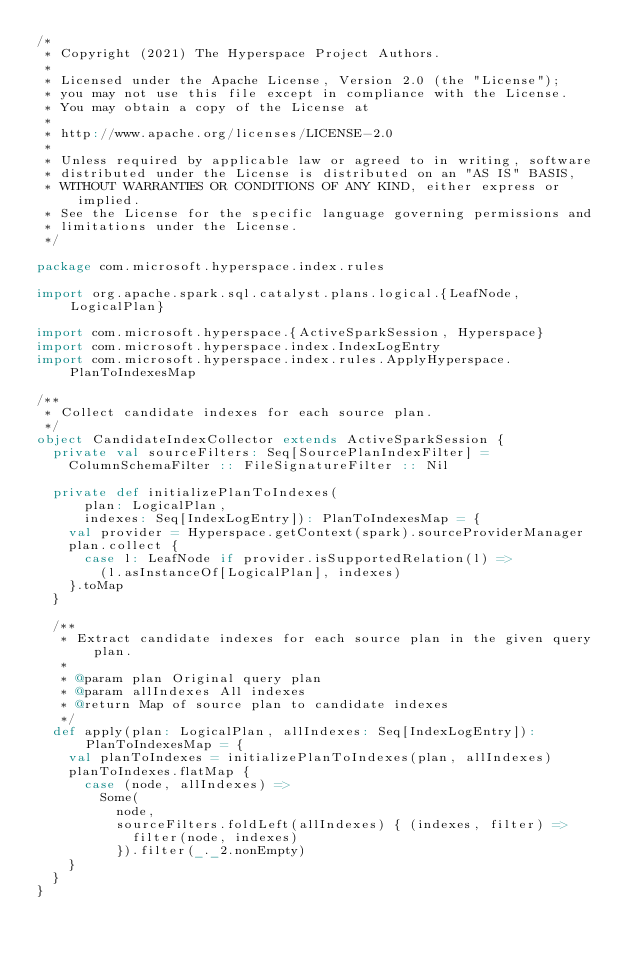<code> <loc_0><loc_0><loc_500><loc_500><_Scala_>/*
 * Copyright (2021) The Hyperspace Project Authors.
 *
 * Licensed under the Apache License, Version 2.0 (the "License");
 * you may not use this file except in compliance with the License.
 * You may obtain a copy of the License at
 *
 * http://www.apache.org/licenses/LICENSE-2.0
 *
 * Unless required by applicable law or agreed to in writing, software
 * distributed under the License is distributed on an "AS IS" BASIS,
 * WITHOUT WARRANTIES OR CONDITIONS OF ANY KIND, either express or implied.
 * See the License for the specific language governing permissions and
 * limitations under the License.
 */

package com.microsoft.hyperspace.index.rules

import org.apache.spark.sql.catalyst.plans.logical.{LeafNode, LogicalPlan}

import com.microsoft.hyperspace.{ActiveSparkSession, Hyperspace}
import com.microsoft.hyperspace.index.IndexLogEntry
import com.microsoft.hyperspace.index.rules.ApplyHyperspace.PlanToIndexesMap

/**
 * Collect candidate indexes for each source plan.
 */
object CandidateIndexCollector extends ActiveSparkSession {
  private val sourceFilters: Seq[SourcePlanIndexFilter] =
    ColumnSchemaFilter :: FileSignatureFilter :: Nil

  private def initializePlanToIndexes(
      plan: LogicalPlan,
      indexes: Seq[IndexLogEntry]): PlanToIndexesMap = {
    val provider = Hyperspace.getContext(spark).sourceProviderManager
    plan.collect {
      case l: LeafNode if provider.isSupportedRelation(l) =>
        (l.asInstanceOf[LogicalPlan], indexes)
    }.toMap
  }

  /**
   * Extract candidate indexes for each source plan in the given query plan.
   *
   * @param plan Original query plan
   * @param allIndexes All indexes
   * @return Map of source plan to candidate indexes
   */
  def apply(plan: LogicalPlan, allIndexes: Seq[IndexLogEntry]): PlanToIndexesMap = {
    val planToIndexes = initializePlanToIndexes(plan, allIndexes)
    planToIndexes.flatMap {
      case (node, allIndexes) =>
        Some(
          node,
          sourceFilters.foldLeft(allIndexes) { (indexes, filter) =>
            filter(node, indexes)
          }).filter(_._2.nonEmpty)
    }
  }
}
</code> 